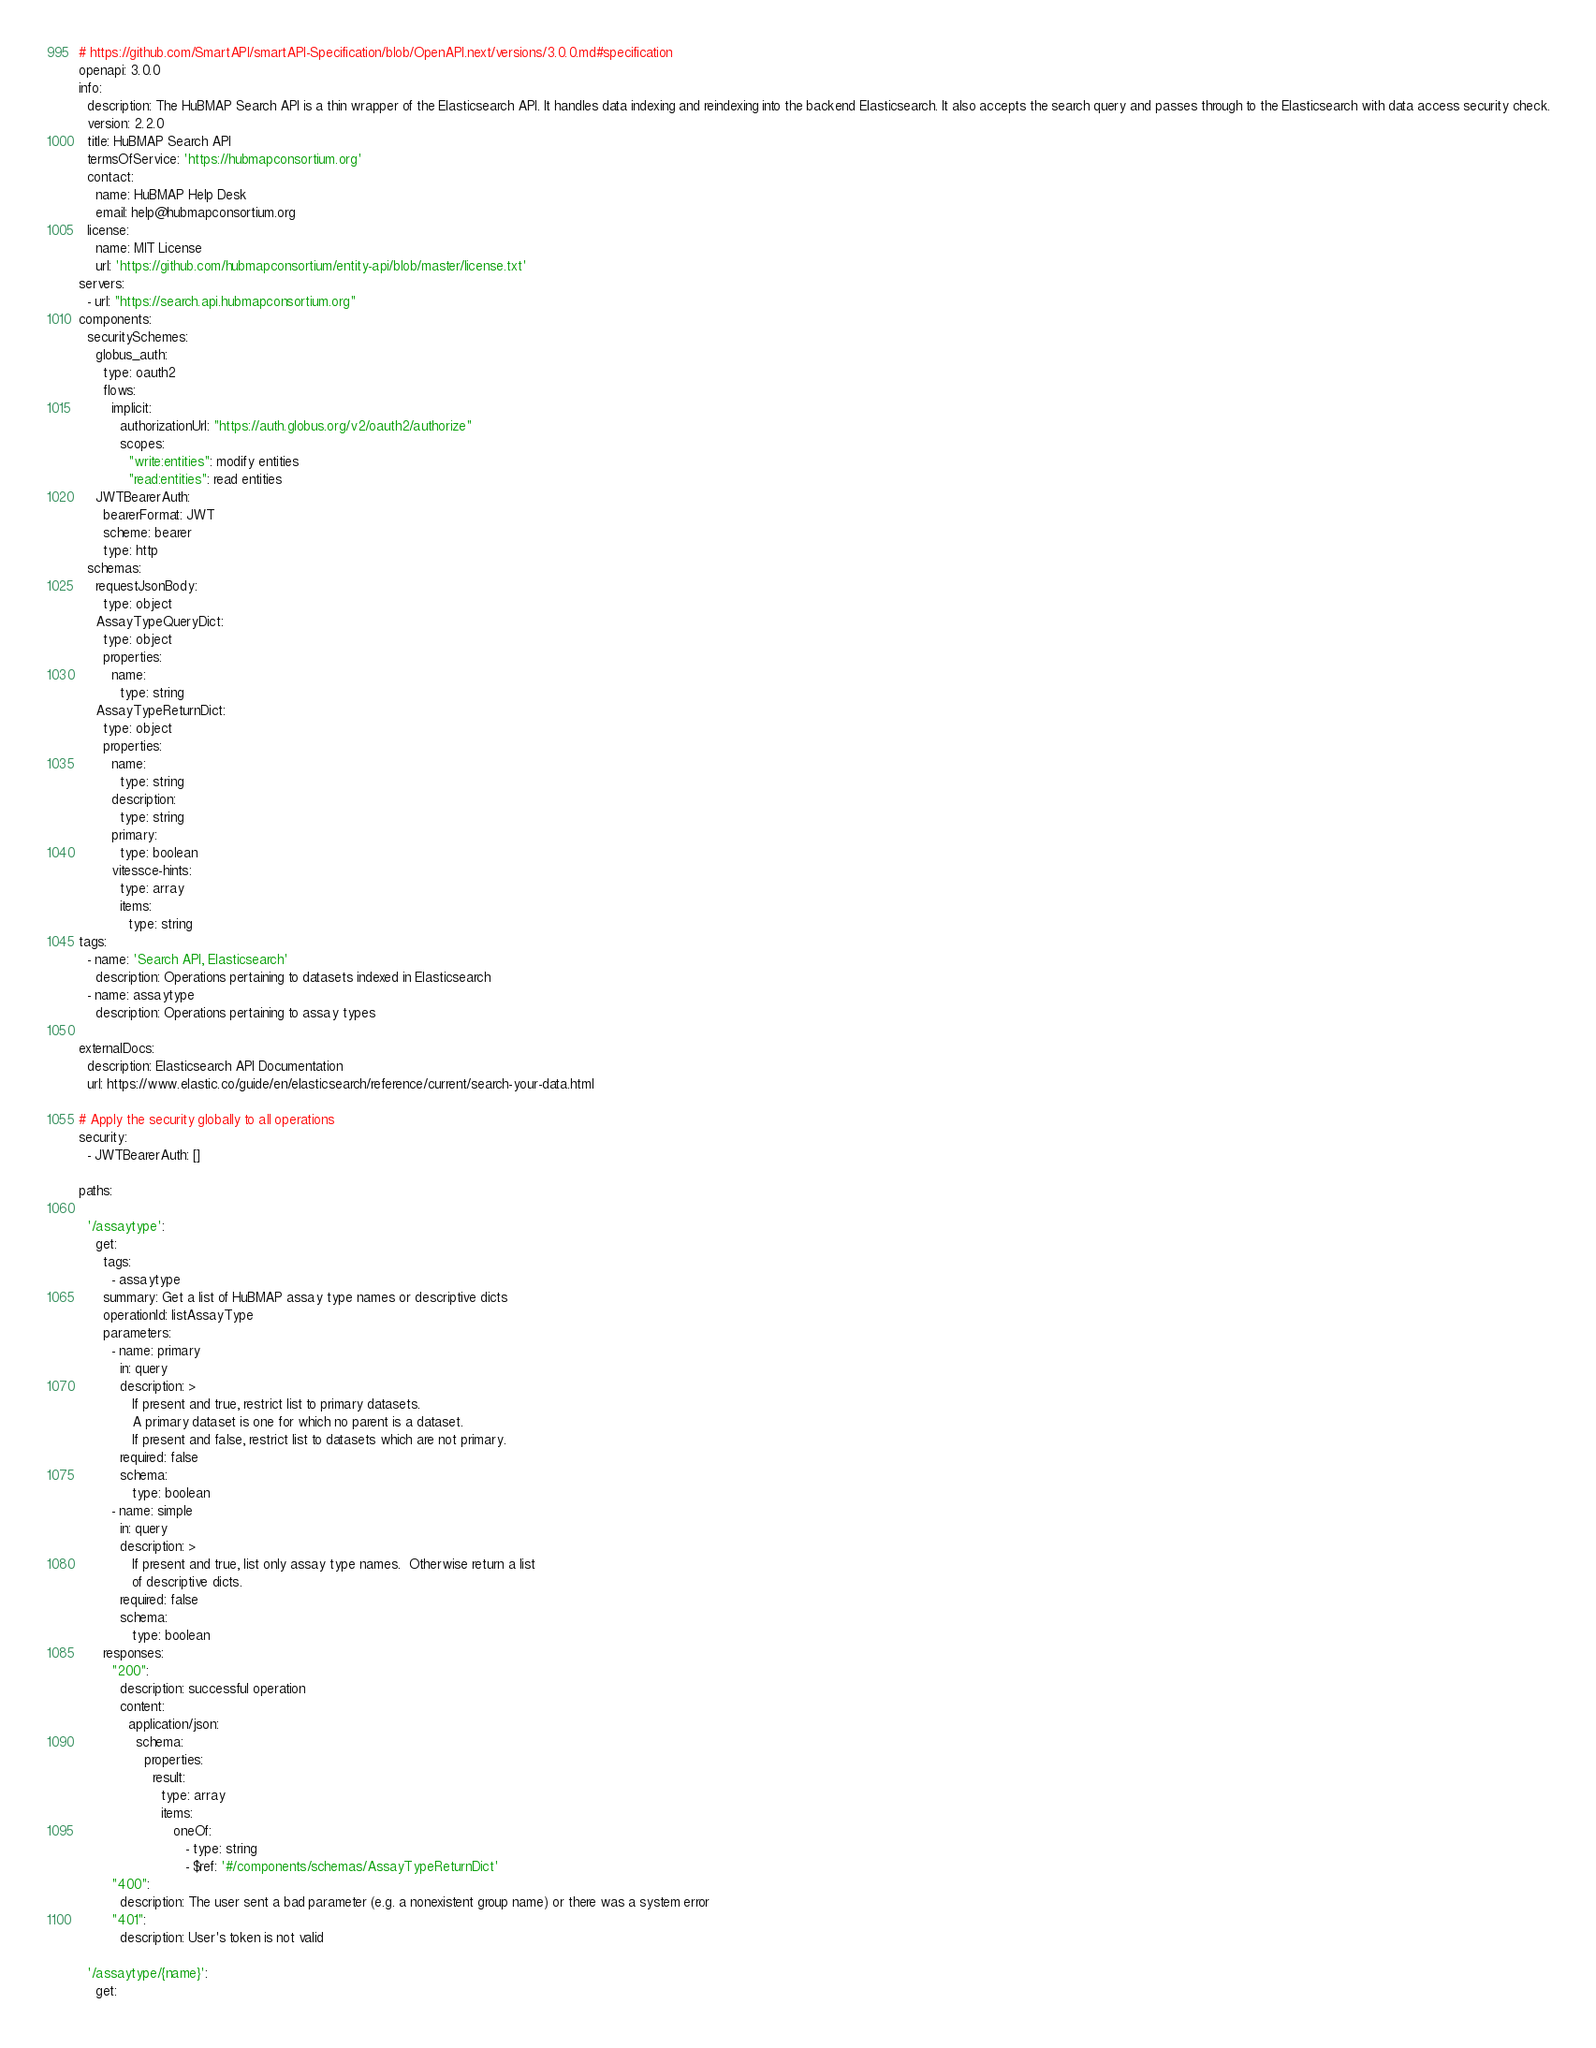Convert code to text. <code><loc_0><loc_0><loc_500><loc_500><_YAML_># https://github.com/SmartAPI/smartAPI-Specification/blob/OpenAPI.next/versions/3.0.0.md#specification
openapi: 3.0.0
info:
  description: The HuBMAP Search API is a thin wrapper of the Elasticsearch API. It handles data indexing and reindexing into the backend Elasticsearch. It also accepts the search query and passes through to the Elasticsearch with data access security check.
  version: 2.2.0
  title: HuBMAP Search API
  termsOfService: 'https://hubmapconsortium.org'
  contact:
    name: HuBMAP Help Desk
    email: help@hubmapconsortium.org
  license:
    name: MIT License
    url: 'https://github.com/hubmapconsortium/entity-api/blob/master/license.txt'
servers:
  - url: "https://search.api.hubmapconsortium.org"
components:
  securitySchemes:
    globus_auth:
      type: oauth2
      flows:
        implicit:
          authorizationUrl: "https://auth.globus.org/v2/oauth2/authorize"
          scopes:
            "write:entities": modify entities
            "read:entities": read entities
    JWTBearerAuth:
      bearerFormat: JWT
      scheme: bearer
      type: http
  schemas:
    requestJsonBody:
      type: object
    AssayTypeQueryDict:
      type: object
      properties:
        name:
          type: string
    AssayTypeReturnDict:
      type: object
      properties:
        name:
          type: string
        description:
          type: string
        primary:
          type: boolean
        vitessce-hints:
          type: array
          items:
            type: string
tags:
  - name: 'Search API, Elasticsearch'
    description: Operations pertaining to datasets indexed in Elasticsearch
  - name: assaytype
    description: Operations pertaining to assay types

externalDocs:
  description: Elasticsearch API Documentation
  url: https://www.elastic.co/guide/en/elasticsearch/reference/current/search-your-data.html
      
# Apply the security globally to all operations
security:
  - JWTBearerAuth: [] 
  
paths:

  '/assaytype':
    get:
      tags:
        - assaytype
      summary: Get a list of HuBMAP assay type names or descriptive dicts
      operationId: listAssayType
      parameters:
        - name: primary
          in: query
          description: >
             If present and true, restrict list to primary datasets.
             A primary dataset is one for which no parent is a dataset.
             If present and false, restrict list to datasets which are not primary.
          required: false
          schema:
             type: boolean
        - name: simple
          in: query
          description: >
             If present and true, list only assay type names.  Otherwise return a list
             of descriptive dicts.
          required: false
          schema:
             type: boolean
      responses:
        "200":
          description: successful operation
          content:
            application/json:
              schema:
                properties:
                  result:
                    type: array
                    items:
                       oneOf:
                          - type: string
                          - $ref: '#/components/schemas/AssayTypeReturnDict'
        "400":
          description: The user sent a bad parameter (e.g. a nonexistent group name) or there was a system error
        "401":
          description: User's token is not valid

  '/assaytype/{name}':
    get:</code> 